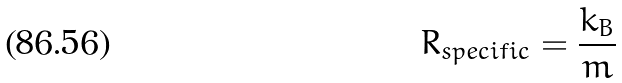Convert formula to latex. <formula><loc_0><loc_0><loc_500><loc_500>R _ { s p e c i f i c } = \frac { k _ { B } } { m }</formula> 